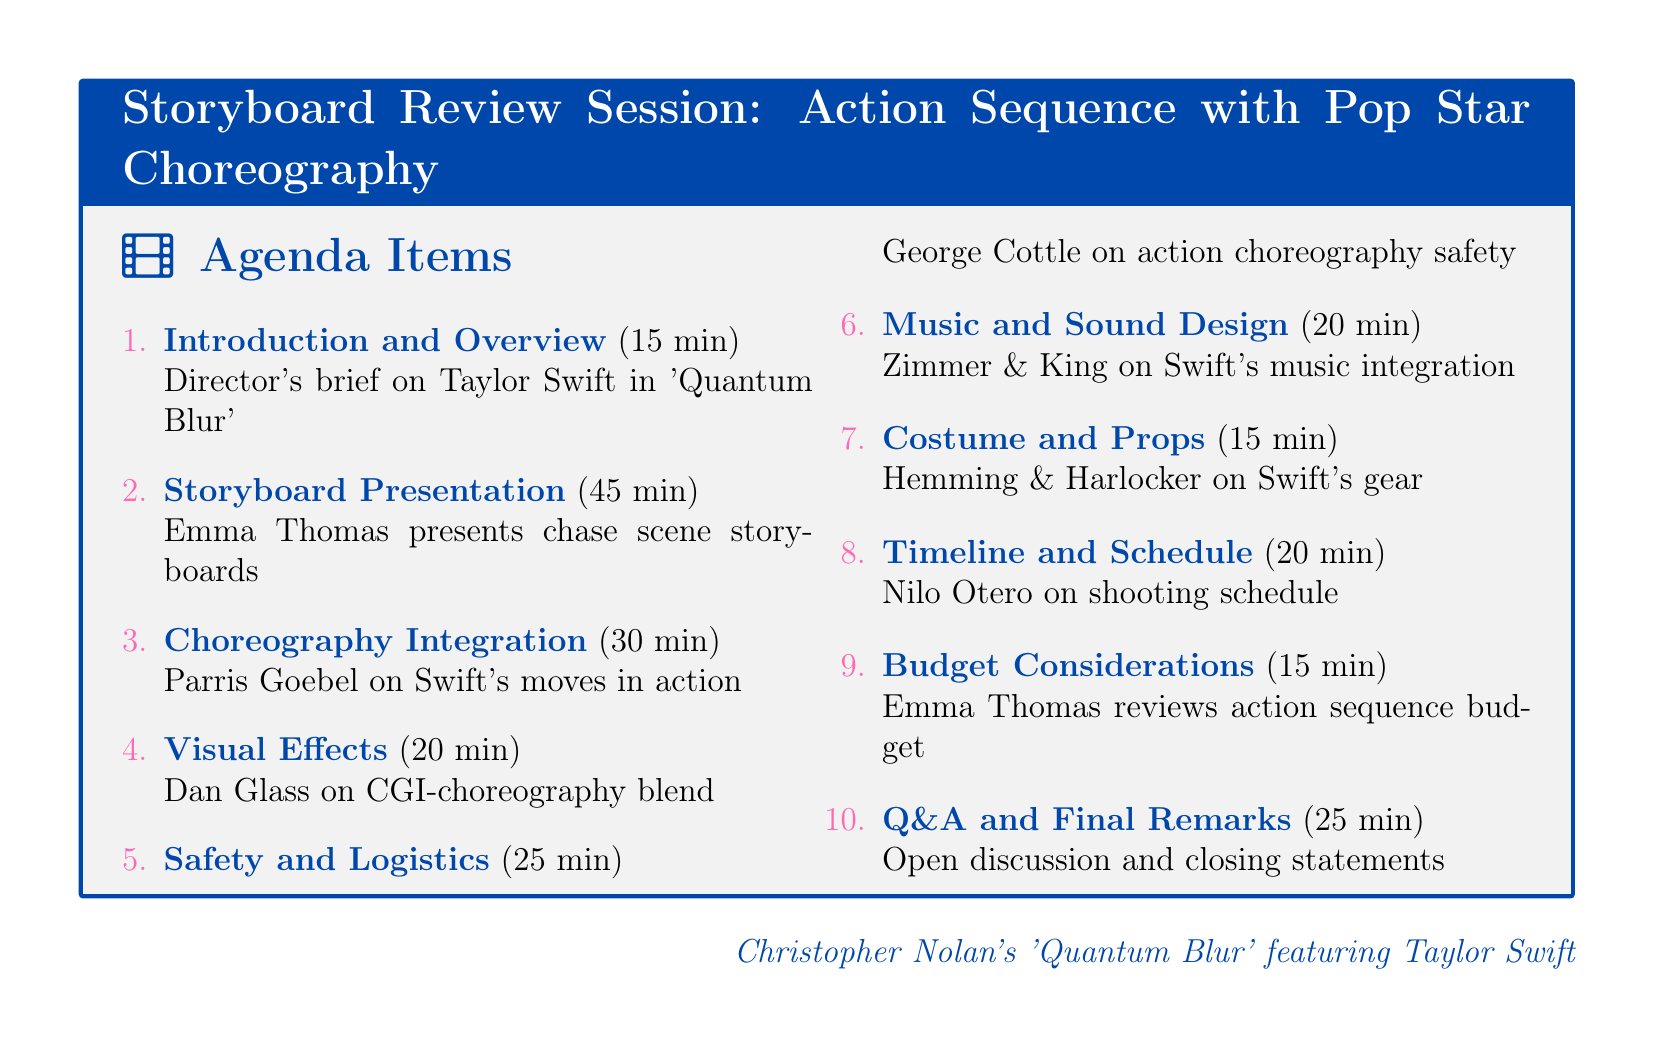What is the total duration of the agenda? The total duration can be calculated by adding the durations of all agenda items: 15 + 45 + 30 + 20 + 25 + 20 + 15 + 20 + 15 + 25 = 305 minutes.
Answer: 305 minutes Who presents the storyboard for the chase scene? The document states that the lead storyboard artist Emma Thomas presents the initial storyboards.
Answer: Emma Thomas How long is the presentation for choreography integration? The document specifies that the choreography integration discussion lasts for 30 minutes.
Answer: 30 minutes What is the main theme of the movie 'Quantum Blur'? The introduction outlines it as a sci-fi thriller featuring Taylor Swift's choreography.
Answer: Sci-fi thriller Which department is responsible for discussing safety measures? The stunt coordinator George Cottle outlines safety measures during the agenda.
Answer: Stunt Coordinator What is the last item on the agenda? The document lists the last agenda item as "Q&A and Final Remarks."
Answer: Q&A and Final Remarks How much time is allocated for music and sound design? According to the agenda, the music and sound design discussion has a duration of 20 minutes.
Answer: 20 minutes Who closes the meeting with final remarks? The closing remarks are made by Christopher Nolan and Taylor Swift according to the agenda details.
Answer: Christopher Nolan and Taylor Swift 